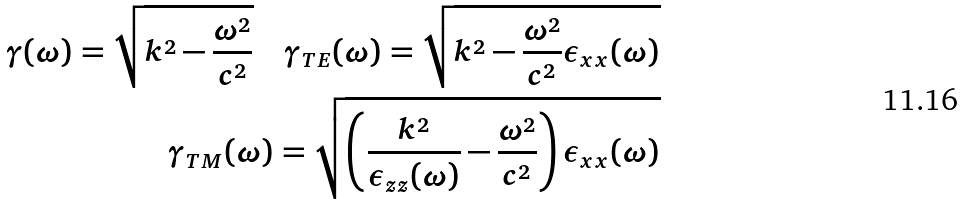Convert formula to latex. <formula><loc_0><loc_0><loc_500><loc_500>\gamma ( \omega ) = \sqrt { k ^ { 2 } - \frac { \omega ^ { 2 } } { c ^ { 2 } } } \quad \gamma _ { T E } ( \omega ) = \sqrt { k ^ { 2 } - \frac { \omega ^ { 2 } } { c ^ { 2 } } \epsilon _ { x x } ( \omega ) } \\ \gamma _ { T M } ( \omega ) = \sqrt { \left ( \frac { k ^ { 2 } } { \epsilon _ { z z } ( \omega ) } - \frac { \omega ^ { 2 } } { c ^ { 2 } } \right ) \epsilon _ { x x } ( \omega ) }</formula> 